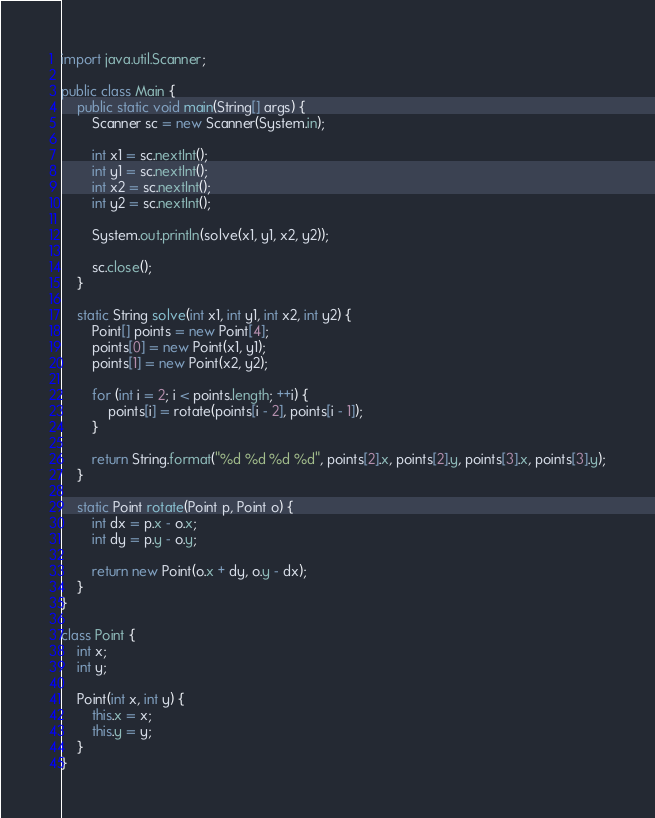Convert code to text. <code><loc_0><loc_0><loc_500><loc_500><_Java_>import java.util.Scanner;

public class Main {
    public static void main(String[] args) {
        Scanner sc = new Scanner(System.in);

        int x1 = sc.nextInt();
        int y1 = sc.nextInt();
        int x2 = sc.nextInt();
        int y2 = sc.nextInt();

        System.out.println(solve(x1, y1, x2, y2));

        sc.close();
    }

    static String solve(int x1, int y1, int x2, int y2) {
        Point[] points = new Point[4];
        points[0] = new Point(x1, y1);
        points[1] = new Point(x2, y2);

        for (int i = 2; i < points.length; ++i) {
            points[i] = rotate(points[i - 2], points[i - 1]);
        }

        return String.format("%d %d %d %d", points[2].x, points[2].y, points[3].x, points[3].y);
    }

    static Point rotate(Point p, Point o) {
        int dx = p.x - o.x;
        int dy = p.y - o.y;

        return new Point(o.x + dy, o.y - dx);
    }
}

class Point {
    int x;
    int y;

    Point(int x, int y) {
        this.x = x;
        this.y = y;
    }
}</code> 